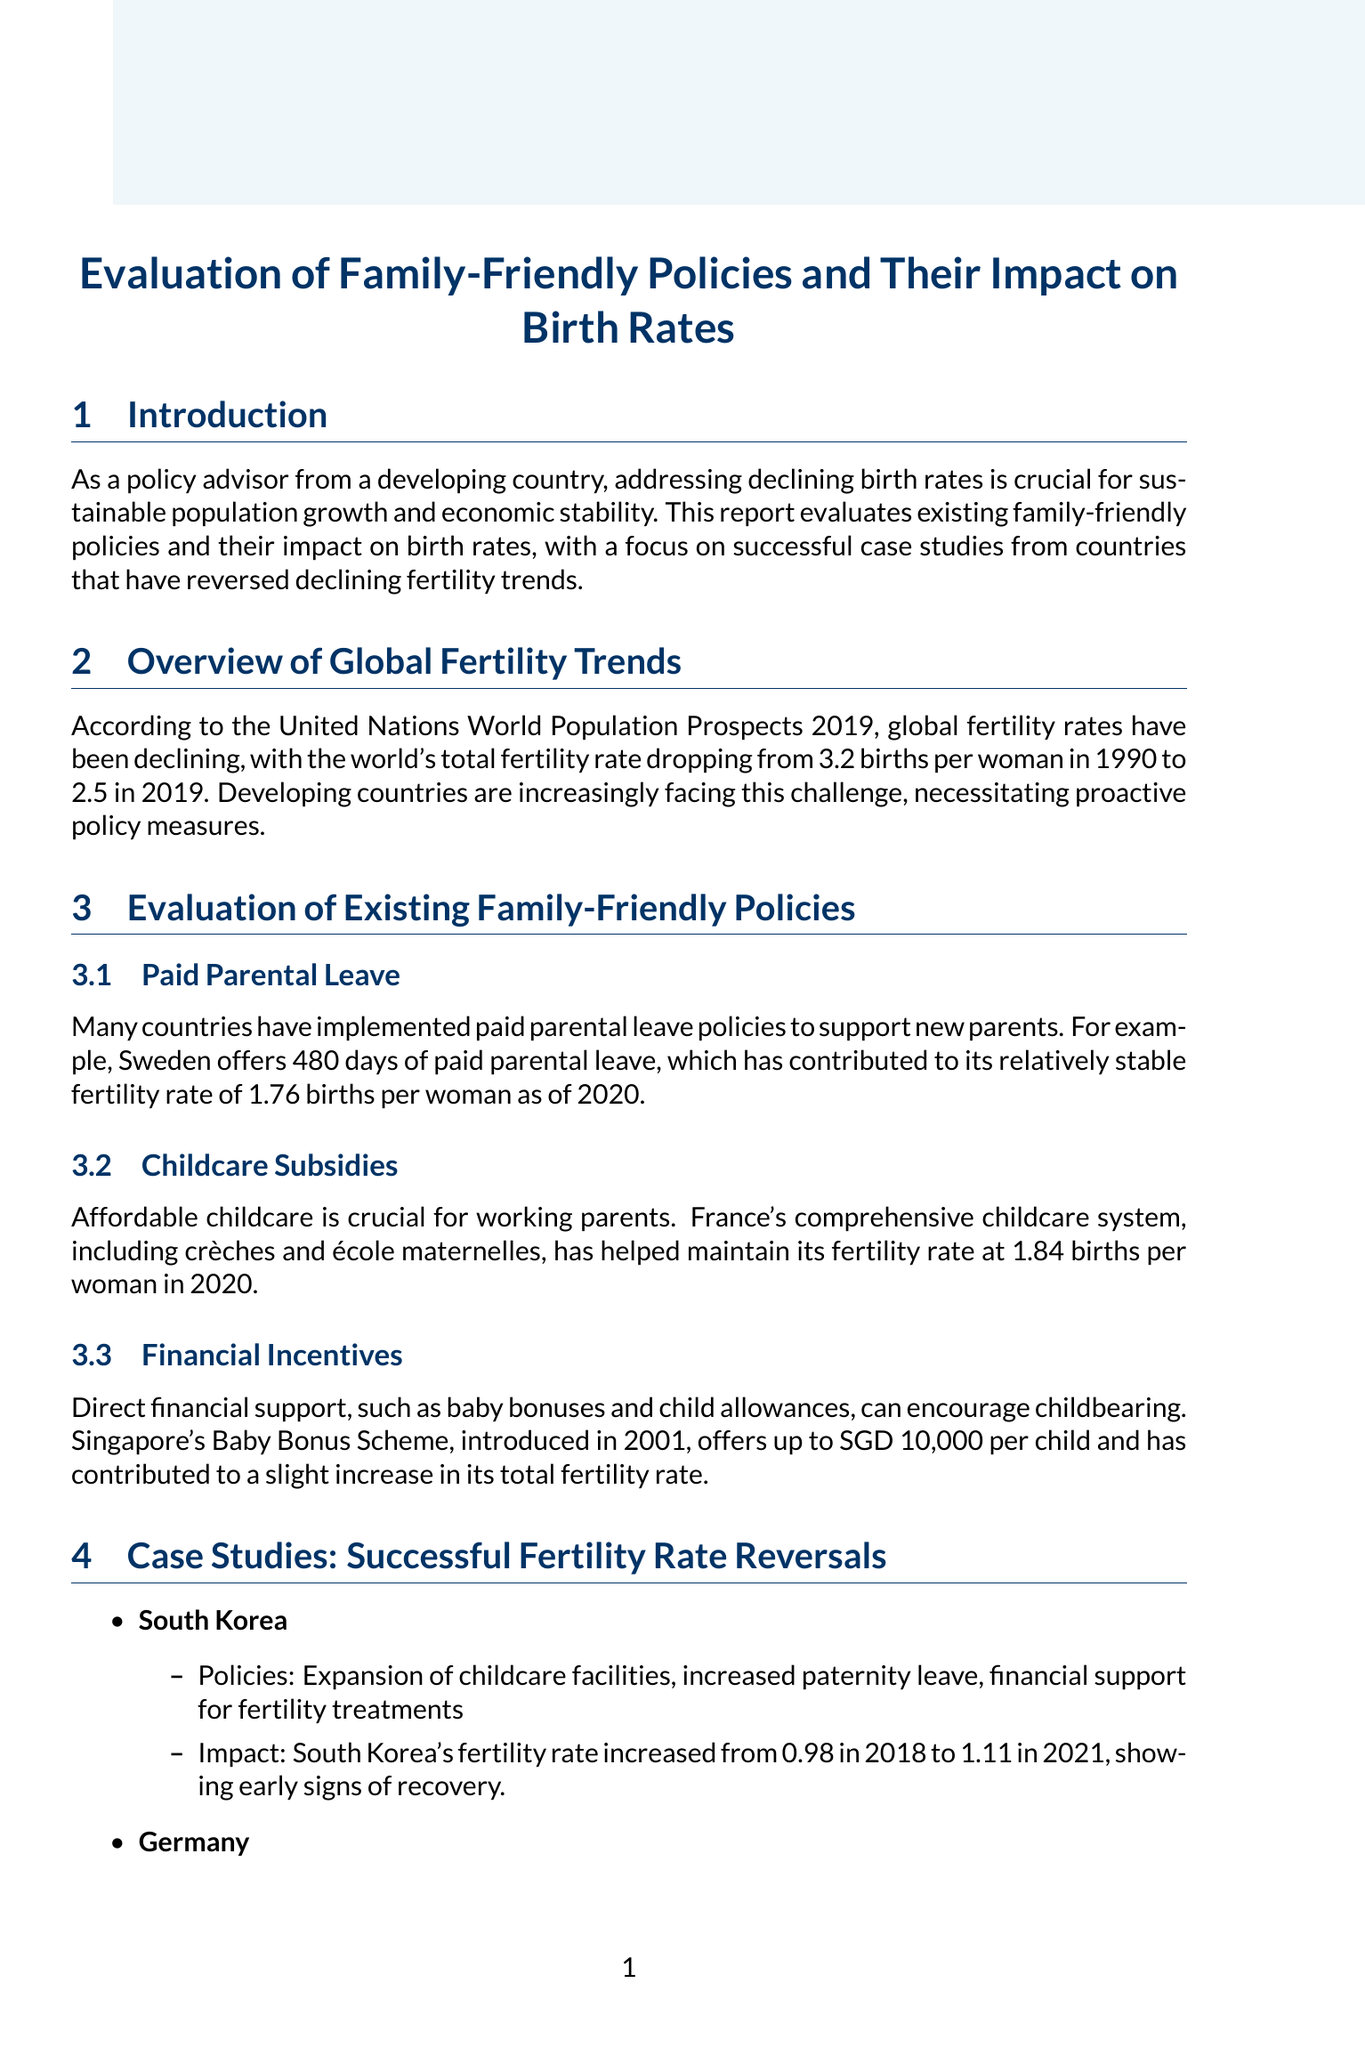What is the focus of the report? The report evaluates existing family-friendly policies and their impact on birth rates, with a focus on successful case studies from countries that have reversed declining fertility trends.
Answer: Family-friendly policies and their impact on birth rates What was the total fertility rate in Sweden as of 2020? The content states that Sweden's fertility rate is relatively stable at 1.76 births per woman as of 2020.
Answer: 1.76 Which country introduced the Baby Bonus Scheme? The report mentions Singapore's Baby Bonus Scheme, which was introduced in 2001.
Answer: Singapore What were the fertility rates in Germany from 2006 to 2020? The fertility rate in Germany rose from 1.33 in 2006 to 1.54 in 2020, according to the document.
Answer: 1.33 to 1.54 What is one of the financial incentives recommended for developing countries? The document suggests introducing baby bonuses, child allowances, and tax breaks for families with children.
Answer: Baby bonuses What specific policy did South Korea implement that contributed to its increase in fertility rates? South Korea expanded childcare facilities, increased paternity leave, and provided financial support for fertility treatments.
Answer: Expansion of childcare facilities What is Dr. Francesco Billari's position? The document states Dr. Francesco Billari is a Professor of Demography at Bocconi University.
Answer: Professor of Demography What year does the United Nations World Population Prospects cite for significant fertility rate decline? The report references a significant drop in fertility rates from 1990 to 2019 based on the UN World Population Prospects.
Answer: 1990 Which country is noted for maintaining a fertility rate of 1.84 births per woman in 2020? The comprehensive childcare system in France is credited with maintaining its fertility rate at 1.84 births per woman in 2020.
Answer: France 